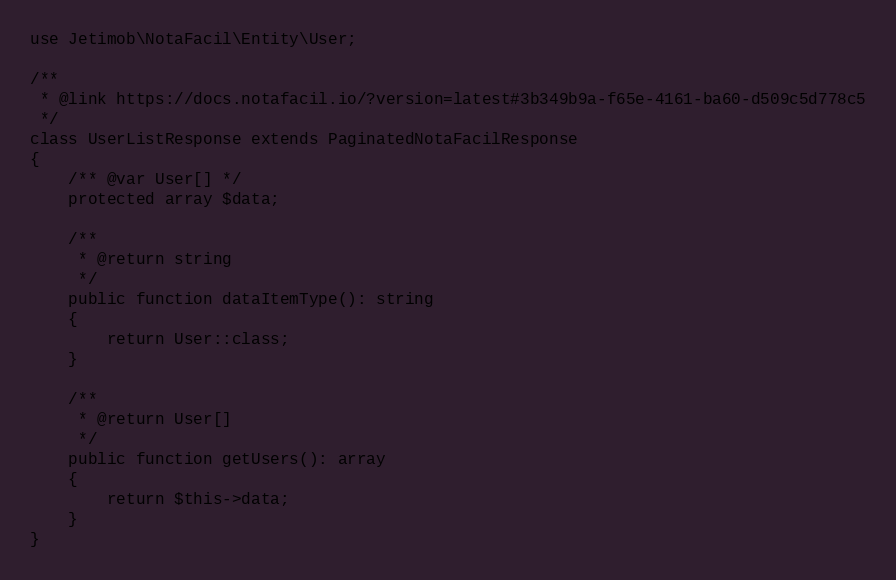<code> <loc_0><loc_0><loc_500><loc_500><_PHP_>use Jetimob\NotaFacil\Entity\User;

/**
 * @link https://docs.notafacil.io/?version=latest#3b349b9a-f65e-4161-ba60-d509c5d778c5
 */
class UserListResponse extends PaginatedNotaFacilResponse
{
    /** @var User[] */
    protected array $data;

    /**
     * @return string
     */
    public function dataItemType(): string
    {
        return User::class;
    }

    /**
     * @return User[]
     */
    public function getUsers(): array
    {
        return $this->data;
    }
}
</code> 